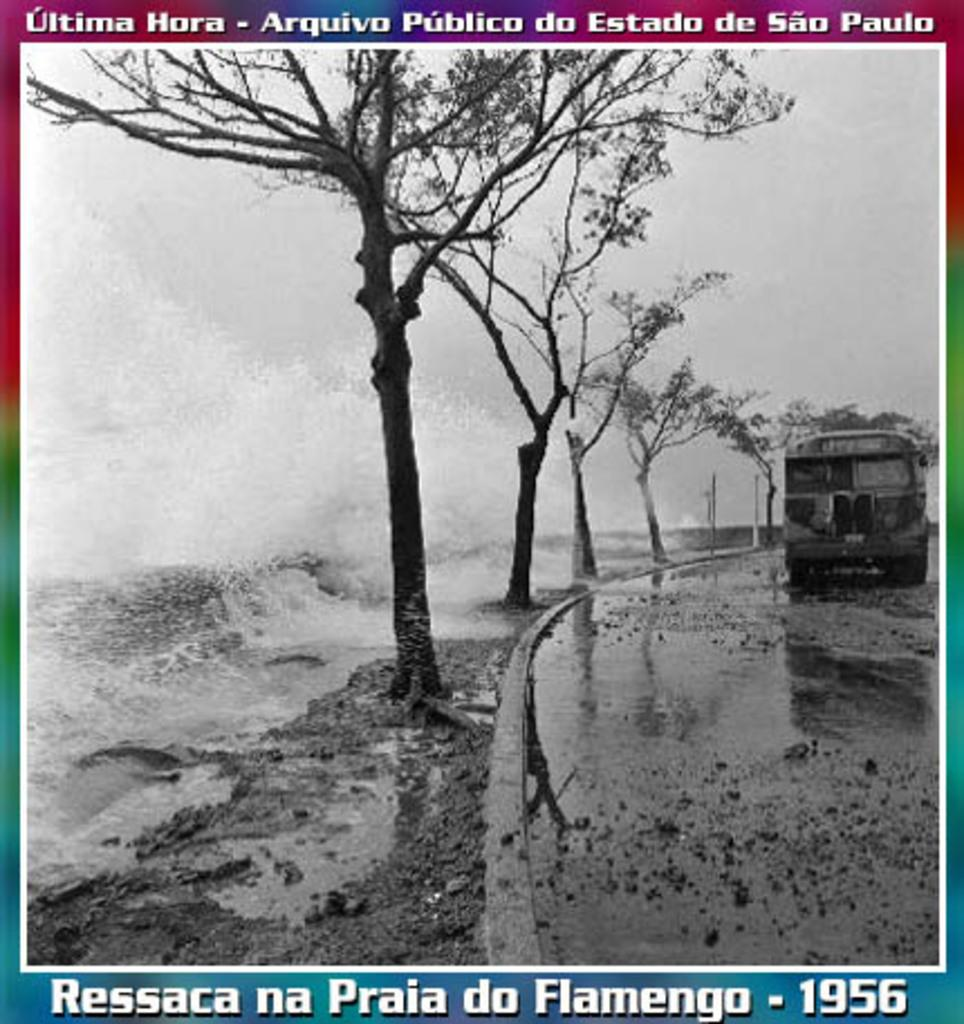Provide a one-sentence caption for the provided image. An original historical image from 1956 ofSao Paulo by Ressaca na Praia do Flamengo. 